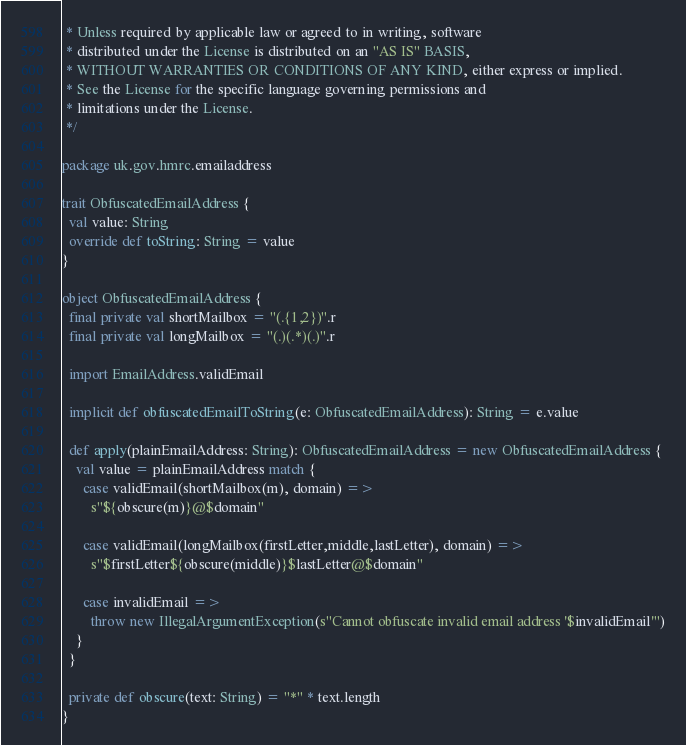<code> <loc_0><loc_0><loc_500><loc_500><_Scala_> * Unless required by applicable law or agreed to in writing, software
 * distributed under the License is distributed on an "AS IS" BASIS,
 * WITHOUT WARRANTIES OR CONDITIONS OF ANY KIND, either express or implied.
 * See the License for the specific language governing permissions and
 * limitations under the License.
 */

package uk.gov.hmrc.emailaddress

trait ObfuscatedEmailAddress {
  val value: String
  override def toString: String = value
}

object ObfuscatedEmailAddress {
  final private val shortMailbox = "(.{1,2})".r
  final private val longMailbox = "(.)(.*)(.)".r

  import EmailAddress.validEmail

  implicit def obfuscatedEmailToString(e: ObfuscatedEmailAddress): String = e.value

  def apply(plainEmailAddress: String): ObfuscatedEmailAddress = new ObfuscatedEmailAddress {
    val value = plainEmailAddress match {
      case validEmail(shortMailbox(m), domain) =>
        s"${obscure(m)}@$domain"

      case validEmail(longMailbox(firstLetter,middle,lastLetter), domain) =>
        s"$firstLetter${obscure(middle)}$lastLetter@$domain"

      case invalidEmail =>
        throw new IllegalArgumentException(s"Cannot obfuscate invalid email address '$invalidEmail'")
    }
  }

  private def obscure(text: String) = "*" * text.length
}
</code> 